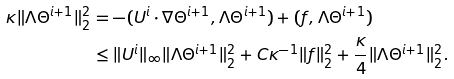<formula> <loc_0><loc_0><loc_500><loc_500>\kappa \| \Lambda \Theta ^ { i + 1 } \| _ { 2 } ^ { 2 } & = - ( U ^ { i } \cdot \nabla \Theta ^ { i + 1 } , \Lambda \Theta ^ { i + 1 } ) + ( f , \Lambda \Theta ^ { i + 1 } ) \\ & \leq \| U ^ { i } \| _ { \infty } \| \Lambda \Theta ^ { i + 1 } \| _ { 2 } ^ { 2 } + C \kappa ^ { - 1 } \| f \| _ { 2 } ^ { 2 } + \frac { \kappa } { 4 } \| \Lambda \Theta ^ { i + 1 } \| _ { 2 } ^ { 2 } .</formula> 